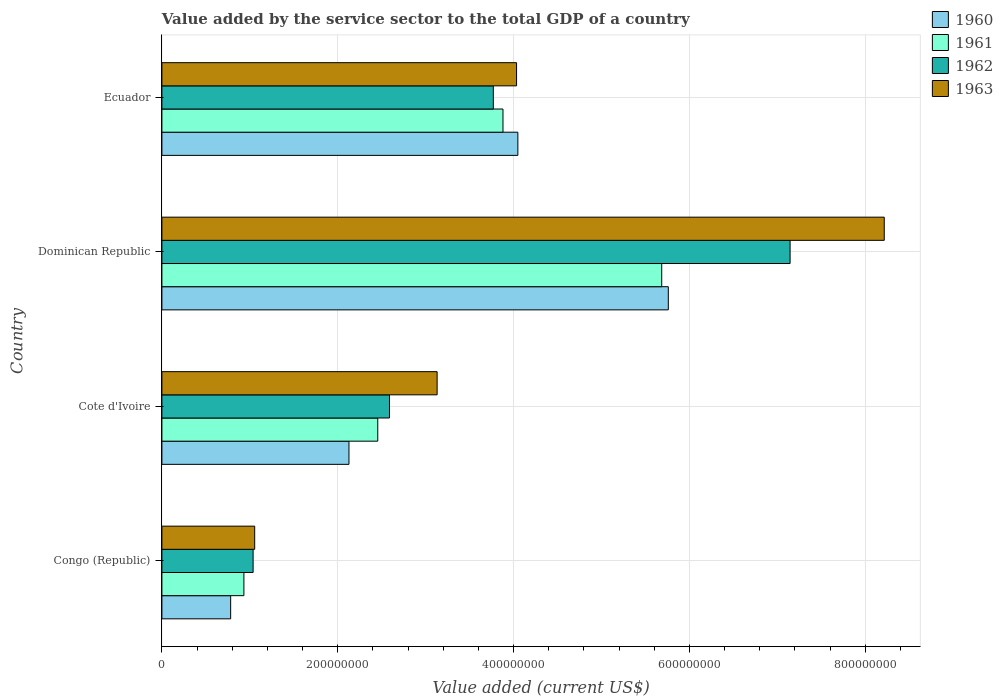How many different coloured bars are there?
Your response must be concise. 4. Are the number of bars per tick equal to the number of legend labels?
Ensure brevity in your answer.  Yes. Are the number of bars on each tick of the Y-axis equal?
Your answer should be very brief. Yes. How many bars are there on the 3rd tick from the top?
Make the answer very short. 4. How many bars are there on the 4th tick from the bottom?
Offer a very short reply. 4. What is the label of the 1st group of bars from the top?
Ensure brevity in your answer.  Ecuador. In how many cases, is the number of bars for a given country not equal to the number of legend labels?
Keep it short and to the point. 0. What is the value added by the service sector to the total GDP in 1963 in Cote d'Ivoire?
Ensure brevity in your answer.  3.13e+08. Across all countries, what is the maximum value added by the service sector to the total GDP in 1963?
Ensure brevity in your answer.  8.22e+08. Across all countries, what is the minimum value added by the service sector to the total GDP in 1962?
Give a very brief answer. 1.04e+08. In which country was the value added by the service sector to the total GDP in 1962 maximum?
Make the answer very short. Dominican Republic. In which country was the value added by the service sector to the total GDP in 1963 minimum?
Your answer should be compact. Congo (Republic). What is the total value added by the service sector to the total GDP in 1962 in the graph?
Your response must be concise. 1.45e+09. What is the difference between the value added by the service sector to the total GDP in 1963 in Congo (Republic) and that in Cote d'Ivoire?
Provide a short and direct response. -2.08e+08. What is the difference between the value added by the service sector to the total GDP in 1963 in Cote d'Ivoire and the value added by the service sector to the total GDP in 1960 in Ecuador?
Keep it short and to the point. -9.18e+07. What is the average value added by the service sector to the total GDP in 1961 per country?
Give a very brief answer. 3.24e+08. What is the difference between the value added by the service sector to the total GDP in 1962 and value added by the service sector to the total GDP in 1963 in Dominican Republic?
Your response must be concise. -1.07e+08. What is the ratio of the value added by the service sector to the total GDP in 1961 in Congo (Republic) to that in Cote d'Ivoire?
Offer a very short reply. 0.38. What is the difference between the highest and the second highest value added by the service sector to the total GDP in 1963?
Your answer should be very brief. 4.18e+08. What is the difference between the highest and the lowest value added by the service sector to the total GDP in 1963?
Your response must be concise. 7.16e+08. In how many countries, is the value added by the service sector to the total GDP in 1963 greater than the average value added by the service sector to the total GDP in 1963 taken over all countries?
Your answer should be very brief. 1. Is the sum of the value added by the service sector to the total GDP in 1960 in Dominican Republic and Ecuador greater than the maximum value added by the service sector to the total GDP in 1961 across all countries?
Your answer should be compact. Yes. Is it the case that in every country, the sum of the value added by the service sector to the total GDP in 1962 and value added by the service sector to the total GDP in 1960 is greater than the sum of value added by the service sector to the total GDP in 1963 and value added by the service sector to the total GDP in 1961?
Keep it short and to the point. No. What does the 1st bar from the bottom in Congo (Republic) represents?
Your answer should be very brief. 1960. Is it the case that in every country, the sum of the value added by the service sector to the total GDP in 1963 and value added by the service sector to the total GDP in 1962 is greater than the value added by the service sector to the total GDP in 1960?
Your answer should be compact. Yes. How many bars are there?
Your answer should be very brief. 16. How many countries are there in the graph?
Your answer should be very brief. 4. What is the difference between two consecutive major ticks on the X-axis?
Make the answer very short. 2.00e+08. Where does the legend appear in the graph?
Ensure brevity in your answer.  Top right. What is the title of the graph?
Keep it short and to the point. Value added by the service sector to the total GDP of a country. Does "1979" appear as one of the legend labels in the graph?
Your response must be concise. No. What is the label or title of the X-axis?
Give a very brief answer. Value added (current US$). What is the label or title of the Y-axis?
Your answer should be very brief. Country. What is the Value added (current US$) in 1960 in Congo (Republic)?
Your answer should be compact. 7.82e+07. What is the Value added (current US$) of 1961 in Congo (Republic)?
Keep it short and to the point. 9.33e+07. What is the Value added (current US$) in 1962 in Congo (Republic)?
Your answer should be very brief. 1.04e+08. What is the Value added (current US$) in 1963 in Congo (Republic)?
Give a very brief answer. 1.06e+08. What is the Value added (current US$) of 1960 in Cote d'Ivoire?
Offer a terse response. 2.13e+08. What is the Value added (current US$) of 1961 in Cote d'Ivoire?
Ensure brevity in your answer.  2.46e+08. What is the Value added (current US$) in 1962 in Cote d'Ivoire?
Your response must be concise. 2.59e+08. What is the Value added (current US$) in 1963 in Cote d'Ivoire?
Provide a short and direct response. 3.13e+08. What is the Value added (current US$) in 1960 in Dominican Republic?
Make the answer very short. 5.76e+08. What is the Value added (current US$) in 1961 in Dominican Republic?
Provide a succinct answer. 5.68e+08. What is the Value added (current US$) in 1962 in Dominican Republic?
Make the answer very short. 7.14e+08. What is the Value added (current US$) of 1963 in Dominican Republic?
Keep it short and to the point. 8.22e+08. What is the Value added (current US$) in 1960 in Ecuador?
Give a very brief answer. 4.05e+08. What is the Value added (current US$) in 1961 in Ecuador?
Ensure brevity in your answer.  3.88e+08. What is the Value added (current US$) in 1962 in Ecuador?
Give a very brief answer. 3.77e+08. What is the Value added (current US$) in 1963 in Ecuador?
Offer a very short reply. 4.03e+08. Across all countries, what is the maximum Value added (current US$) of 1960?
Make the answer very short. 5.76e+08. Across all countries, what is the maximum Value added (current US$) in 1961?
Offer a very short reply. 5.68e+08. Across all countries, what is the maximum Value added (current US$) in 1962?
Keep it short and to the point. 7.14e+08. Across all countries, what is the maximum Value added (current US$) of 1963?
Give a very brief answer. 8.22e+08. Across all countries, what is the minimum Value added (current US$) in 1960?
Make the answer very short. 7.82e+07. Across all countries, what is the minimum Value added (current US$) of 1961?
Keep it short and to the point. 9.33e+07. Across all countries, what is the minimum Value added (current US$) of 1962?
Give a very brief answer. 1.04e+08. Across all countries, what is the minimum Value added (current US$) in 1963?
Offer a very short reply. 1.06e+08. What is the total Value added (current US$) of 1960 in the graph?
Ensure brevity in your answer.  1.27e+09. What is the total Value added (current US$) of 1961 in the graph?
Make the answer very short. 1.30e+09. What is the total Value added (current US$) in 1962 in the graph?
Make the answer very short. 1.45e+09. What is the total Value added (current US$) in 1963 in the graph?
Your answer should be very brief. 1.64e+09. What is the difference between the Value added (current US$) in 1960 in Congo (Republic) and that in Cote d'Ivoire?
Keep it short and to the point. -1.35e+08. What is the difference between the Value added (current US$) in 1961 in Congo (Republic) and that in Cote d'Ivoire?
Provide a succinct answer. -1.52e+08. What is the difference between the Value added (current US$) in 1962 in Congo (Republic) and that in Cote d'Ivoire?
Ensure brevity in your answer.  -1.55e+08. What is the difference between the Value added (current US$) of 1963 in Congo (Republic) and that in Cote d'Ivoire?
Your answer should be compact. -2.08e+08. What is the difference between the Value added (current US$) in 1960 in Congo (Republic) and that in Dominican Republic?
Your answer should be compact. -4.98e+08. What is the difference between the Value added (current US$) in 1961 in Congo (Republic) and that in Dominican Republic?
Provide a short and direct response. -4.75e+08. What is the difference between the Value added (current US$) in 1962 in Congo (Republic) and that in Dominican Republic?
Keep it short and to the point. -6.11e+08. What is the difference between the Value added (current US$) in 1963 in Congo (Republic) and that in Dominican Republic?
Make the answer very short. -7.16e+08. What is the difference between the Value added (current US$) of 1960 in Congo (Republic) and that in Ecuador?
Provide a succinct answer. -3.27e+08. What is the difference between the Value added (current US$) in 1961 in Congo (Republic) and that in Ecuador?
Ensure brevity in your answer.  -2.95e+08. What is the difference between the Value added (current US$) in 1962 in Congo (Republic) and that in Ecuador?
Offer a very short reply. -2.73e+08. What is the difference between the Value added (current US$) in 1963 in Congo (Republic) and that in Ecuador?
Offer a terse response. -2.98e+08. What is the difference between the Value added (current US$) of 1960 in Cote d'Ivoire and that in Dominican Republic?
Offer a very short reply. -3.63e+08. What is the difference between the Value added (current US$) in 1961 in Cote d'Ivoire and that in Dominican Republic?
Offer a terse response. -3.23e+08. What is the difference between the Value added (current US$) in 1962 in Cote d'Ivoire and that in Dominican Republic?
Provide a short and direct response. -4.56e+08. What is the difference between the Value added (current US$) of 1963 in Cote d'Ivoire and that in Dominican Republic?
Make the answer very short. -5.09e+08. What is the difference between the Value added (current US$) of 1960 in Cote d'Ivoire and that in Ecuador?
Provide a short and direct response. -1.92e+08. What is the difference between the Value added (current US$) of 1961 in Cote d'Ivoire and that in Ecuador?
Keep it short and to the point. -1.42e+08. What is the difference between the Value added (current US$) in 1962 in Cote d'Ivoire and that in Ecuador?
Give a very brief answer. -1.18e+08. What is the difference between the Value added (current US$) of 1963 in Cote d'Ivoire and that in Ecuador?
Keep it short and to the point. -9.04e+07. What is the difference between the Value added (current US$) in 1960 in Dominican Republic and that in Ecuador?
Make the answer very short. 1.71e+08. What is the difference between the Value added (current US$) in 1961 in Dominican Republic and that in Ecuador?
Ensure brevity in your answer.  1.81e+08. What is the difference between the Value added (current US$) of 1962 in Dominican Republic and that in Ecuador?
Provide a short and direct response. 3.38e+08. What is the difference between the Value added (current US$) in 1963 in Dominican Republic and that in Ecuador?
Keep it short and to the point. 4.18e+08. What is the difference between the Value added (current US$) in 1960 in Congo (Republic) and the Value added (current US$) in 1961 in Cote d'Ivoire?
Your answer should be compact. -1.67e+08. What is the difference between the Value added (current US$) of 1960 in Congo (Republic) and the Value added (current US$) of 1962 in Cote d'Ivoire?
Ensure brevity in your answer.  -1.81e+08. What is the difference between the Value added (current US$) of 1960 in Congo (Republic) and the Value added (current US$) of 1963 in Cote d'Ivoire?
Your answer should be compact. -2.35e+08. What is the difference between the Value added (current US$) of 1961 in Congo (Republic) and the Value added (current US$) of 1962 in Cote d'Ivoire?
Keep it short and to the point. -1.66e+08. What is the difference between the Value added (current US$) of 1961 in Congo (Republic) and the Value added (current US$) of 1963 in Cote d'Ivoire?
Your answer should be very brief. -2.20e+08. What is the difference between the Value added (current US$) of 1962 in Congo (Republic) and the Value added (current US$) of 1963 in Cote d'Ivoire?
Your answer should be very brief. -2.09e+08. What is the difference between the Value added (current US$) in 1960 in Congo (Republic) and the Value added (current US$) in 1961 in Dominican Republic?
Provide a short and direct response. -4.90e+08. What is the difference between the Value added (current US$) in 1960 in Congo (Republic) and the Value added (current US$) in 1962 in Dominican Republic?
Make the answer very short. -6.36e+08. What is the difference between the Value added (current US$) in 1960 in Congo (Republic) and the Value added (current US$) in 1963 in Dominican Republic?
Keep it short and to the point. -7.43e+08. What is the difference between the Value added (current US$) in 1961 in Congo (Republic) and the Value added (current US$) in 1962 in Dominican Republic?
Make the answer very short. -6.21e+08. What is the difference between the Value added (current US$) in 1961 in Congo (Republic) and the Value added (current US$) in 1963 in Dominican Republic?
Make the answer very short. -7.28e+08. What is the difference between the Value added (current US$) in 1962 in Congo (Republic) and the Value added (current US$) in 1963 in Dominican Republic?
Your answer should be very brief. -7.18e+08. What is the difference between the Value added (current US$) in 1960 in Congo (Republic) and the Value added (current US$) in 1961 in Ecuador?
Keep it short and to the point. -3.10e+08. What is the difference between the Value added (current US$) in 1960 in Congo (Republic) and the Value added (current US$) in 1962 in Ecuador?
Your answer should be compact. -2.99e+08. What is the difference between the Value added (current US$) of 1960 in Congo (Republic) and the Value added (current US$) of 1963 in Ecuador?
Offer a very short reply. -3.25e+08. What is the difference between the Value added (current US$) of 1961 in Congo (Republic) and the Value added (current US$) of 1962 in Ecuador?
Offer a terse response. -2.84e+08. What is the difference between the Value added (current US$) in 1961 in Congo (Republic) and the Value added (current US$) in 1963 in Ecuador?
Ensure brevity in your answer.  -3.10e+08. What is the difference between the Value added (current US$) in 1962 in Congo (Republic) and the Value added (current US$) in 1963 in Ecuador?
Provide a succinct answer. -3.00e+08. What is the difference between the Value added (current US$) in 1960 in Cote d'Ivoire and the Value added (current US$) in 1961 in Dominican Republic?
Provide a short and direct response. -3.56e+08. What is the difference between the Value added (current US$) of 1960 in Cote d'Ivoire and the Value added (current US$) of 1962 in Dominican Republic?
Ensure brevity in your answer.  -5.02e+08. What is the difference between the Value added (current US$) in 1960 in Cote d'Ivoire and the Value added (current US$) in 1963 in Dominican Republic?
Provide a succinct answer. -6.09e+08. What is the difference between the Value added (current US$) of 1961 in Cote d'Ivoire and the Value added (current US$) of 1962 in Dominican Republic?
Give a very brief answer. -4.69e+08. What is the difference between the Value added (current US$) of 1961 in Cote d'Ivoire and the Value added (current US$) of 1963 in Dominican Republic?
Your answer should be very brief. -5.76e+08. What is the difference between the Value added (current US$) of 1962 in Cote d'Ivoire and the Value added (current US$) of 1963 in Dominican Republic?
Give a very brief answer. -5.63e+08. What is the difference between the Value added (current US$) of 1960 in Cote d'Ivoire and the Value added (current US$) of 1961 in Ecuador?
Offer a very short reply. -1.75e+08. What is the difference between the Value added (current US$) of 1960 in Cote d'Ivoire and the Value added (current US$) of 1962 in Ecuador?
Ensure brevity in your answer.  -1.64e+08. What is the difference between the Value added (current US$) in 1960 in Cote d'Ivoire and the Value added (current US$) in 1963 in Ecuador?
Offer a terse response. -1.91e+08. What is the difference between the Value added (current US$) of 1961 in Cote d'Ivoire and the Value added (current US$) of 1962 in Ecuador?
Your answer should be very brief. -1.31e+08. What is the difference between the Value added (current US$) in 1961 in Cote d'Ivoire and the Value added (current US$) in 1963 in Ecuador?
Your answer should be very brief. -1.58e+08. What is the difference between the Value added (current US$) in 1962 in Cote d'Ivoire and the Value added (current US$) in 1963 in Ecuador?
Ensure brevity in your answer.  -1.45e+08. What is the difference between the Value added (current US$) of 1960 in Dominican Republic and the Value added (current US$) of 1961 in Ecuador?
Provide a succinct answer. 1.88e+08. What is the difference between the Value added (current US$) in 1960 in Dominican Republic and the Value added (current US$) in 1962 in Ecuador?
Ensure brevity in your answer.  1.99e+08. What is the difference between the Value added (current US$) of 1960 in Dominican Republic and the Value added (current US$) of 1963 in Ecuador?
Give a very brief answer. 1.73e+08. What is the difference between the Value added (current US$) of 1961 in Dominican Republic and the Value added (current US$) of 1962 in Ecuador?
Give a very brief answer. 1.92e+08. What is the difference between the Value added (current US$) in 1961 in Dominican Republic and the Value added (current US$) in 1963 in Ecuador?
Give a very brief answer. 1.65e+08. What is the difference between the Value added (current US$) of 1962 in Dominican Republic and the Value added (current US$) of 1963 in Ecuador?
Make the answer very short. 3.11e+08. What is the average Value added (current US$) in 1960 per country?
Keep it short and to the point. 3.18e+08. What is the average Value added (current US$) in 1961 per country?
Provide a short and direct response. 3.24e+08. What is the average Value added (current US$) of 1962 per country?
Ensure brevity in your answer.  3.64e+08. What is the average Value added (current US$) in 1963 per country?
Your response must be concise. 4.11e+08. What is the difference between the Value added (current US$) of 1960 and Value added (current US$) of 1961 in Congo (Republic)?
Keep it short and to the point. -1.51e+07. What is the difference between the Value added (current US$) in 1960 and Value added (current US$) in 1962 in Congo (Republic)?
Your answer should be very brief. -2.55e+07. What is the difference between the Value added (current US$) in 1960 and Value added (current US$) in 1963 in Congo (Republic)?
Your answer should be very brief. -2.73e+07. What is the difference between the Value added (current US$) of 1961 and Value added (current US$) of 1962 in Congo (Republic)?
Your response must be concise. -1.05e+07. What is the difference between the Value added (current US$) of 1961 and Value added (current US$) of 1963 in Congo (Republic)?
Offer a very short reply. -1.23e+07. What is the difference between the Value added (current US$) of 1962 and Value added (current US$) of 1963 in Congo (Republic)?
Your response must be concise. -1.79e+06. What is the difference between the Value added (current US$) in 1960 and Value added (current US$) in 1961 in Cote d'Ivoire?
Offer a terse response. -3.28e+07. What is the difference between the Value added (current US$) of 1960 and Value added (current US$) of 1962 in Cote d'Ivoire?
Offer a very short reply. -4.61e+07. What is the difference between the Value added (current US$) of 1960 and Value added (current US$) of 1963 in Cote d'Ivoire?
Provide a short and direct response. -1.00e+08. What is the difference between the Value added (current US$) in 1961 and Value added (current US$) in 1962 in Cote d'Ivoire?
Your answer should be very brief. -1.33e+07. What is the difference between the Value added (current US$) in 1961 and Value added (current US$) in 1963 in Cote d'Ivoire?
Your answer should be very brief. -6.75e+07. What is the difference between the Value added (current US$) of 1962 and Value added (current US$) of 1963 in Cote d'Ivoire?
Keep it short and to the point. -5.42e+07. What is the difference between the Value added (current US$) of 1960 and Value added (current US$) of 1961 in Dominican Republic?
Give a very brief answer. 7.50e+06. What is the difference between the Value added (current US$) of 1960 and Value added (current US$) of 1962 in Dominican Republic?
Make the answer very short. -1.39e+08. What is the difference between the Value added (current US$) in 1960 and Value added (current US$) in 1963 in Dominican Republic?
Offer a very short reply. -2.46e+08. What is the difference between the Value added (current US$) in 1961 and Value added (current US$) in 1962 in Dominican Republic?
Provide a succinct answer. -1.46e+08. What is the difference between the Value added (current US$) in 1961 and Value added (current US$) in 1963 in Dominican Republic?
Keep it short and to the point. -2.53e+08. What is the difference between the Value added (current US$) of 1962 and Value added (current US$) of 1963 in Dominican Republic?
Provide a short and direct response. -1.07e+08. What is the difference between the Value added (current US$) in 1960 and Value added (current US$) in 1961 in Ecuador?
Your answer should be compact. 1.69e+07. What is the difference between the Value added (current US$) in 1960 and Value added (current US$) in 1962 in Ecuador?
Provide a succinct answer. 2.79e+07. What is the difference between the Value added (current US$) in 1960 and Value added (current US$) in 1963 in Ecuador?
Your answer should be very brief. 1.47e+06. What is the difference between the Value added (current US$) in 1961 and Value added (current US$) in 1962 in Ecuador?
Your response must be concise. 1.10e+07. What is the difference between the Value added (current US$) in 1961 and Value added (current US$) in 1963 in Ecuador?
Make the answer very short. -1.54e+07. What is the difference between the Value added (current US$) in 1962 and Value added (current US$) in 1963 in Ecuador?
Your answer should be compact. -2.64e+07. What is the ratio of the Value added (current US$) of 1960 in Congo (Republic) to that in Cote d'Ivoire?
Your response must be concise. 0.37. What is the ratio of the Value added (current US$) of 1961 in Congo (Republic) to that in Cote d'Ivoire?
Offer a terse response. 0.38. What is the ratio of the Value added (current US$) in 1962 in Congo (Republic) to that in Cote d'Ivoire?
Offer a very short reply. 0.4. What is the ratio of the Value added (current US$) in 1963 in Congo (Republic) to that in Cote d'Ivoire?
Provide a succinct answer. 0.34. What is the ratio of the Value added (current US$) in 1960 in Congo (Republic) to that in Dominican Republic?
Keep it short and to the point. 0.14. What is the ratio of the Value added (current US$) of 1961 in Congo (Republic) to that in Dominican Republic?
Offer a very short reply. 0.16. What is the ratio of the Value added (current US$) of 1962 in Congo (Republic) to that in Dominican Republic?
Ensure brevity in your answer.  0.15. What is the ratio of the Value added (current US$) of 1963 in Congo (Republic) to that in Dominican Republic?
Your answer should be compact. 0.13. What is the ratio of the Value added (current US$) of 1960 in Congo (Republic) to that in Ecuador?
Keep it short and to the point. 0.19. What is the ratio of the Value added (current US$) in 1961 in Congo (Republic) to that in Ecuador?
Provide a short and direct response. 0.24. What is the ratio of the Value added (current US$) in 1962 in Congo (Republic) to that in Ecuador?
Ensure brevity in your answer.  0.28. What is the ratio of the Value added (current US$) in 1963 in Congo (Republic) to that in Ecuador?
Offer a terse response. 0.26. What is the ratio of the Value added (current US$) of 1960 in Cote d'Ivoire to that in Dominican Republic?
Make the answer very short. 0.37. What is the ratio of the Value added (current US$) of 1961 in Cote d'Ivoire to that in Dominican Republic?
Offer a very short reply. 0.43. What is the ratio of the Value added (current US$) in 1962 in Cote d'Ivoire to that in Dominican Republic?
Provide a short and direct response. 0.36. What is the ratio of the Value added (current US$) in 1963 in Cote d'Ivoire to that in Dominican Republic?
Provide a succinct answer. 0.38. What is the ratio of the Value added (current US$) of 1960 in Cote d'Ivoire to that in Ecuador?
Keep it short and to the point. 0.53. What is the ratio of the Value added (current US$) of 1961 in Cote d'Ivoire to that in Ecuador?
Give a very brief answer. 0.63. What is the ratio of the Value added (current US$) of 1962 in Cote d'Ivoire to that in Ecuador?
Your answer should be very brief. 0.69. What is the ratio of the Value added (current US$) in 1963 in Cote d'Ivoire to that in Ecuador?
Offer a very short reply. 0.78. What is the ratio of the Value added (current US$) of 1960 in Dominican Republic to that in Ecuador?
Provide a succinct answer. 1.42. What is the ratio of the Value added (current US$) of 1961 in Dominican Republic to that in Ecuador?
Your response must be concise. 1.47. What is the ratio of the Value added (current US$) of 1962 in Dominican Republic to that in Ecuador?
Your answer should be compact. 1.9. What is the ratio of the Value added (current US$) of 1963 in Dominican Republic to that in Ecuador?
Make the answer very short. 2.04. What is the difference between the highest and the second highest Value added (current US$) of 1960?
Provide a short and direct response. 1.71e+08. What is the difference between the highest and the second highest Value added (current US$) of 1961?
Your answer should be compact. 1.81e+08. What is the difference between the highest and the second highest Value added (current US$) in 1962?
Your answer should be compact. 3.38e+08. What is the difference between the highest and the second highest Value added (current US$) in 1963?
Provide a succinct answer. 4.18e+08. What is the difference between the highest and the lowest Value added (current US$) in 1960?
Make the answer very short. 4.98e+08. What is the difference between the highest and the lowest Value added (current US$) in 1961?
Give a very brief answer. 4.75e+08. What is the difference between the highest and the lowest Value added (current US$) of 1962?
Offer a terse response. 6.11e+08. What is the difference between the highest and the lowest Value added (current US$) in 1963?
Your answer should be compact. 7.16e+08. 